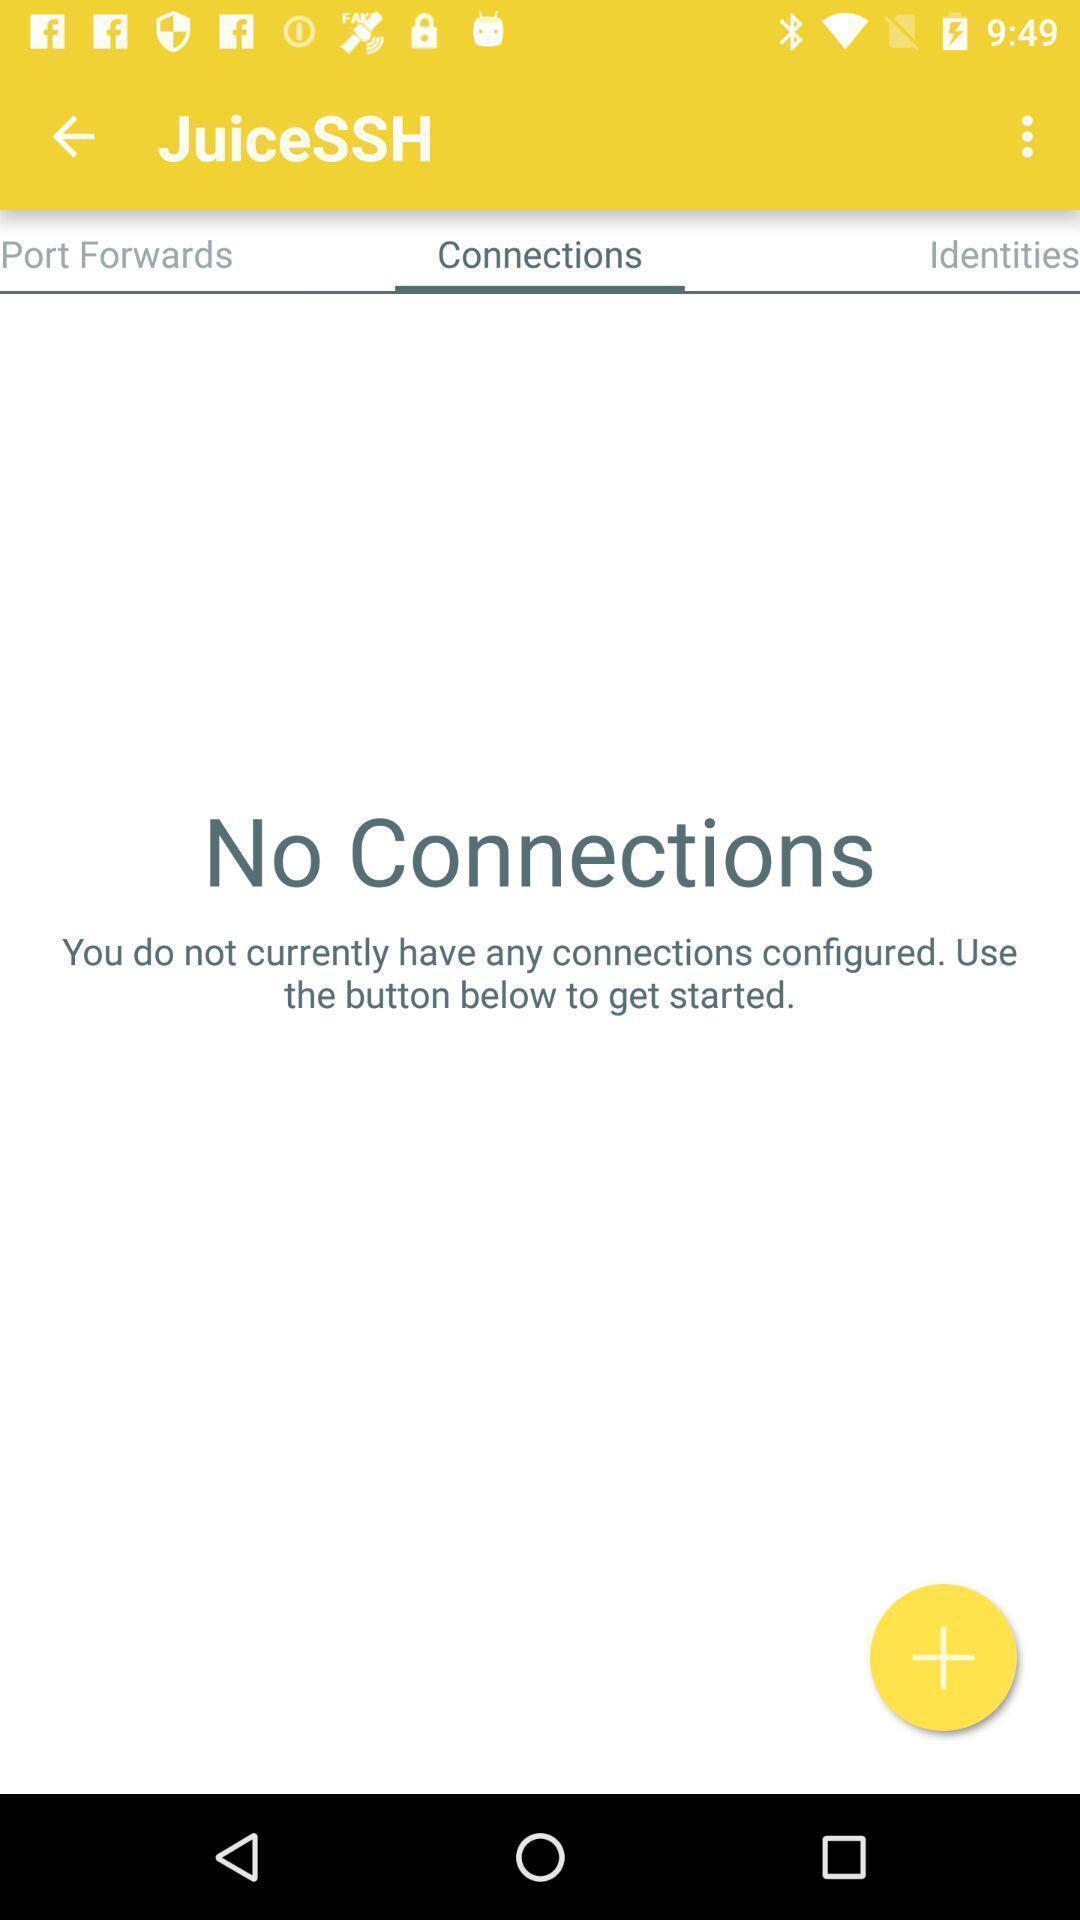Provide a description of this screenshot. Page showing information about connections. 